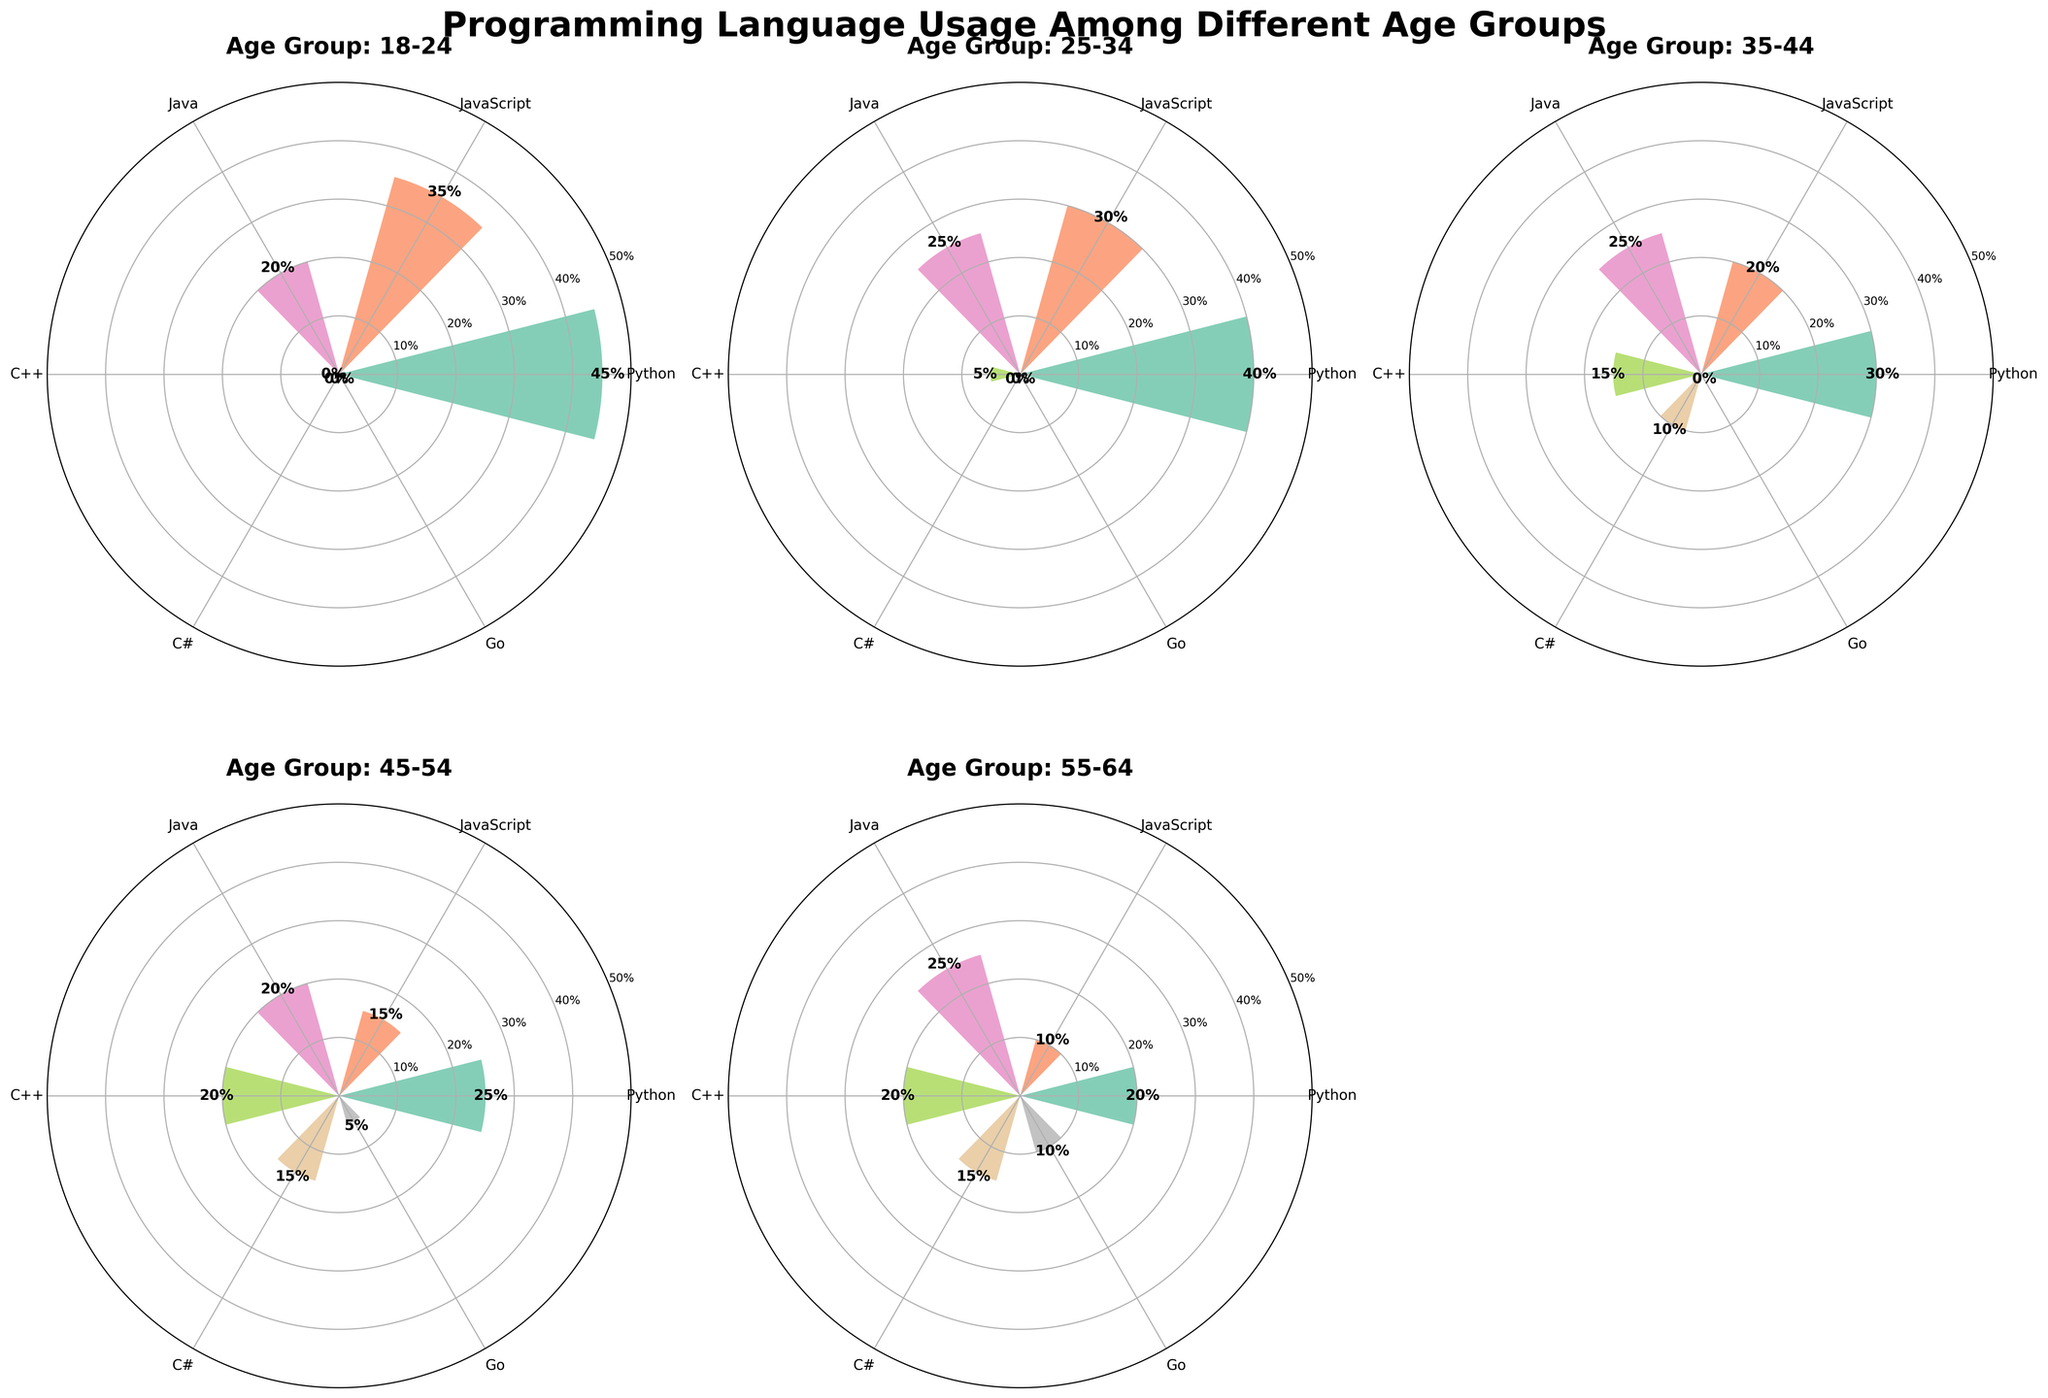What is the title of the figure? The title is typically at the top center of the figure. In this case, it reads "Programming Language Usage Among Different Age Groups," which clearly indicates the topic of the visualization.
Answer: Programming Language Usage Among Different Age Groups Which programming language has the highest usage among the 25-34 age group? Look for the 25-34 age group's subplot and identify the bar with the highest value. The highest bar corresponds to Python, with a 40% usage.
Answer: Python How does the percentage usage of Java for the 35-44 age group compare to the C++ usage in the same group? In the 35-44 age group subplot, Java has a usage of 25%, while C++ has a usage of 15%. This indicates that Java is used more than C++ by 10 percentage points.
Answer: Java is used 10% more than C++ What’s the total percentage usage of programming languages in the 18-24 age group? Sum up the percentages of all the programming languages in the 18-24 age group: 45 (Python) + 35 (JavaScript) + 20 (Java) which equals 100%.
Answer: 100% Which age group has the highest diversity of programming languages based on the number of languages used? Count the number of different programming languages in each age group. The 45-54 age group uses Python, JavaScript, Java, C++, C#, and Go, making it the group with the highest diversity of six languages.
Answer: 45-54 What is the least used programming language within the 55-64 age group? Locate the 55-64 age group subplot and identify the bar with the smallest height. Go is the least used programming language with a 10% usage.
Answer: Go Which age group has the highest usage of JavaScript? Compare the usage of JavaScript across all age groups. The age group 18-24 has the highest usage of JavaScript at 35%.
Answer: 18-24 Is the percentage usage of Python higher or lower than Java in the 55-64 age group? By how much? In the 55-64 age group, Python is used 20%, while Java is used 25%. Therefore, Python is used 5 percentage points less than Java.
Answer: Lower by 5% What is the average percentage usage of C++ across all age groups? Sum the C++ usage percentages: 5 (25-34) + 15 (35-44) + 20 (45-54) + 20 (55-64) = 60. The number of groups is 4. So, the average is 60 / 4 = 15%.
Answer: 15% How does the usage of Go compare between the 45-54 age group and the 55-64 age group? In the 45-54 age group, the usage of Go is 5%, while in the 55-64 age group, it is 10%. This shows that Go usage doubles from 45-54 to 55-64.
Answer: It doubles 